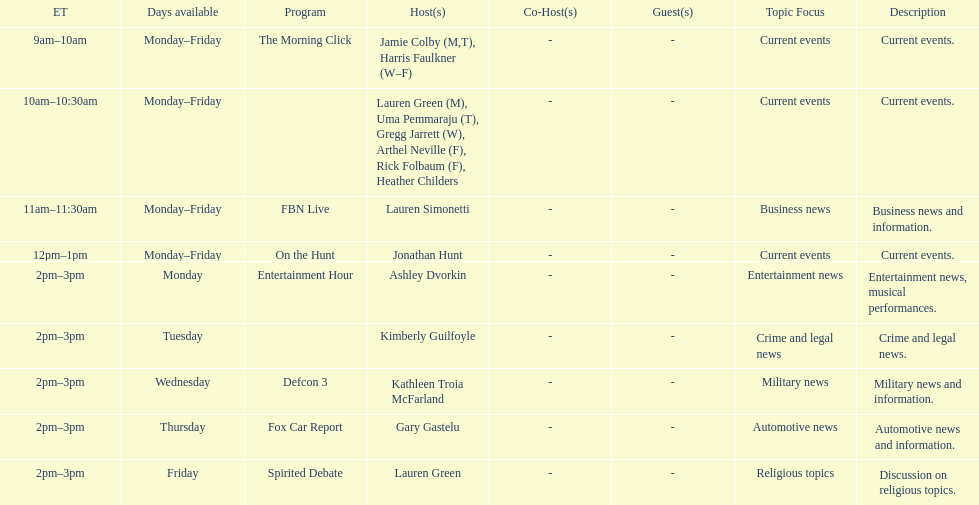What are the names of all the hosts? Jamie Colby (M,T), Harris Faulkner (W–F), Lauren Green (M), Uma Pemmaraju (T), Gregg Jarrett (W), Arthel Neville (F), Rick Folbaum (F), Heather Childers, Lauren Simonetti, Jonathan Hunt, Ashley Dvorkin, Kimberly Guilfoyle, Kathleen Troia McFarland, Gary Gastelu, Lauren Green. What hosts have a show on friday? Jamie Colby (M,T), Harris Faulkner (W–F), Lauren Green (M), Uma Pemmaraju (T), Gregg Jarrett (W), Arthel Neville (F), Rick Folbaum (F), Heather Childers, Lauren Simonetti, Jonathan Hunt, Lauren Green. Parse the full table. {'header': ['ET', 'Days available', 'Program', 'Host(s)', 'Co-Host(s)', 'Guest(s)', 'Topic Focus', 'Description'], 'rows': [['9am–10am', 'Monday–Friday', 'The Morning Click', 'Jamie Colby (M,T), Harris Faulkner (W–F)', '-', '-', 'Current events', 'Current events.'], ['10am–10:30am', 'Monday–Friday', '', 'Lauren Green (M), Uma Pemmaraju (T), Gregg Jarrett (W), Arthel Neville (F), Rick Folbaum (F), Heather Childers', '-', '-', 'Current events', 'Current events.'], ['11am–11:30am', 'Monday–Friday', 'FBN Live', 'Lauren Simonetti', '-', '-', 'Business news', 'Business news and information.'], ['12pm–1pm', 'Monday–Friday', 'On the Hunt', 'Jonathan Hunt', '-', '-', 'Current events', 'Current events.'], ['2pm–3pm', 'Monday', 'Entertainment Hour', 'Ashley Dvorkin', '-', '-', 'Entertainment news', 'Entertainment news, musical performances.'], ['2pm–3pm', 'Tuesday', '', 'Kimberly Guilfoyle', '-', '-', 'Crime and legal news', 'Crime and legal news.'], ['2pm–3pm', 'Wednesday', 'Defcon 3', 'Kathleen Troia McFarland', '-', '-', 'Military news', 'Military news and information.'], ['2pm–3pm', 'Thursday', 'Fox Car Report', 'Gary Gastelu', '-', '-', 'Automotive news', 'Automotive news and information.'], ['2pm–3pm', 'Friday', 'Spirited Debate', 'Lauren Green', '-', '-', 'Religious topics', 'Discussion on religious topics.']]} Of these hosts, which is the only host with only friday available? Lauren Green. 